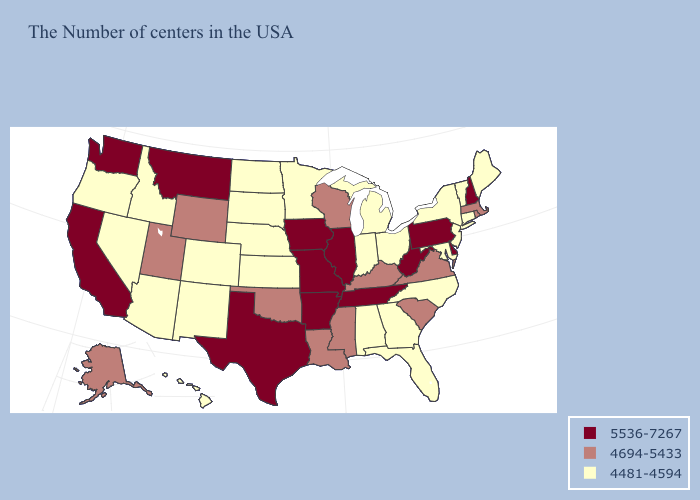Among the states that border Virginia , does North Carolina have the lowest value?
Be succinct. Yes. Does the first symbol in the legend represent the smallest category?
Short answer required. No. Does Montana have a lower value than Wyoming?
Short answer required. No. Name the states that have a value in the range 5536-7267?
Answer briefly. New Hampshire, Delaware, Pennsylvania, West Virginia, Tennessee, Illinois, Missouri, Arkansas, Iowa, Texas, Montana, California, Washington. What is the value of Maine?
Give a very brief answer. 4481-4594. What is the highest value in the USA?
Be succinct. 5536-7267. Name the states that have a value in the range 4694-5433?
Write a very short answer. Massachusetts, Rhode Island, Virginia, South Carolina, Kentucky, Wisconsin, Mississippi, Louisiana, Oklahoma, Wyoming, Utah, Alaska. Which states have the highest value in the USA?
Quick response, please. New Hampshire, Delaware, Pennsylvania, West Virginia, Tennessee, Illinois, Missouri, Arkansas, Iowa, Texas, Montana, California, Washington. Name the states that have a value in the range 4481-4594?
Keep it brief. Maine, Vermont, Connecticut, New York, New Jersey, Maryland, North Carolina, Ohio, Florida, Georgia, Michigan, Indiana, Alabama, Minnesota, Kansas, Nebraska, South Dakota, North Dakota, Colorado, New Mexico, Arizona, Idaho, Nevada, Oregon, Hawaii. Name the states that have a value in the range 4481-4594?
Answer briefly. Maine, Vermont, Connecticut, New York, New Jersey, Maryland, North Carolina, Ohio, Florida, Georgia, Michigan, Indiana, Alabama, Minnesota, Kansas, Nebraska, South Dakota, North Dakota, Colorado, New Mexico, Arizona, Idaho, Nevada, Oregon, Hawaii. Does Colorado have the lowest value in the West?
Quick response, please. Yes. What is the value of West Virginia?
Write a very short answer. 5536-7267. Name the states that have a value in the range 4481-4594?
Be succinct. Maine, Vermont, Connecticut, New York, New Jersey, Maryland, North Carolina, Ohio, Florida, Georgia, Michigan, Indiana, Alabama, Minnesota, Kansas, Nebraska, South Dakota, North Dakota, Colorado, New Mexico, Arizona, Idaho, Nevada, Oregon, Hawaii. Name the states that have a value in the range 5536-7267?
Answer briefly. New Hampshire, Delaware, Pennsylvania, West Virginia, Tennessee, Illinois, Missouri, Arkansas, Iowa, Texas, Montana, California, Washington. Name the states that have a value in the range 4481-4594?
Short answer required. Maine, Vermont, Connecticut, New York, New Jersey, Maryland, North Carolina, Ohio, Florida, Georgia, Michigan, Indiana, Alabama, Minnesota, Kansas, Nebraska, South Dakota, North Dakota, Colorado, New Mexico, Arizona, Idaho, Nevada, Oregon, Hawaii. 